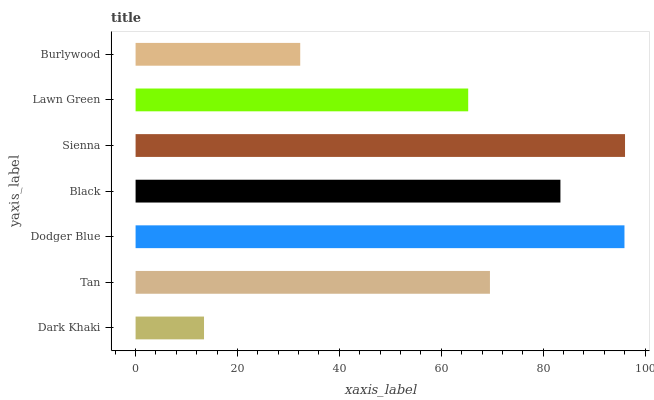Is Dark Khaki the minimum?
Answer yes or no. Yes. Is Sienna the maximum?
Answer yes or no. Yes. Is Tan the minimum?
Answer yes or no. No. Is Tan the maximum?
Answer yes or no. No. Is Tan greater than Dark Khaki?
Answer yes or no. Yes. Is Dark Khaki less than Tan?
Answer yes or no. Yes. Is Dark Khaki greater than Tan?
Answer yes or no. No. Is Tan less than Dark Khaki?
Answer yes or no. No. Is Tan the high median?
Answer yes or no. Yes. Is Tan the low median?
Answer yes or no. Yes. Is Dodger Blue the high median?
Answer yes or no. No. Is Lawn Green the low median?
Answer yes or no. No. 